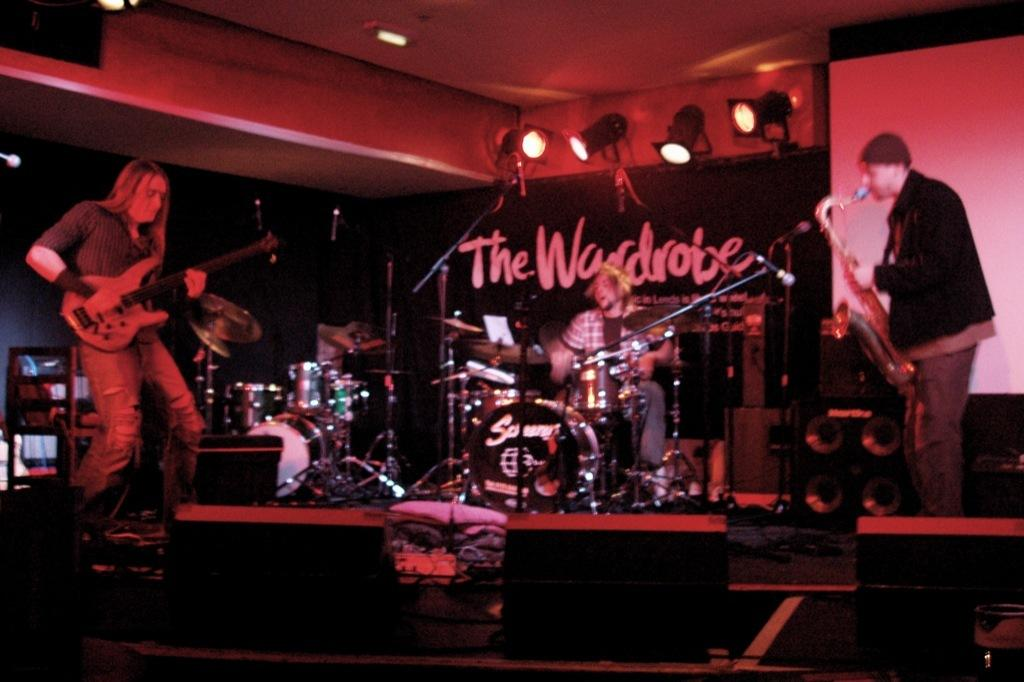What are the people in the image doing? The people in the image are holding musical instruments. Can you describe the specific action of one of the individuals in the image? Yes, there is a man sitting and playing drums in the image. What type of war is depicted in the image? There is no war depicted in the image; it features people playing musical instruments. What question is being asked by the person holding the guitar in the image? There is no person holding a guitar asking a question in the image; the image only shows people playing musical instruments. 